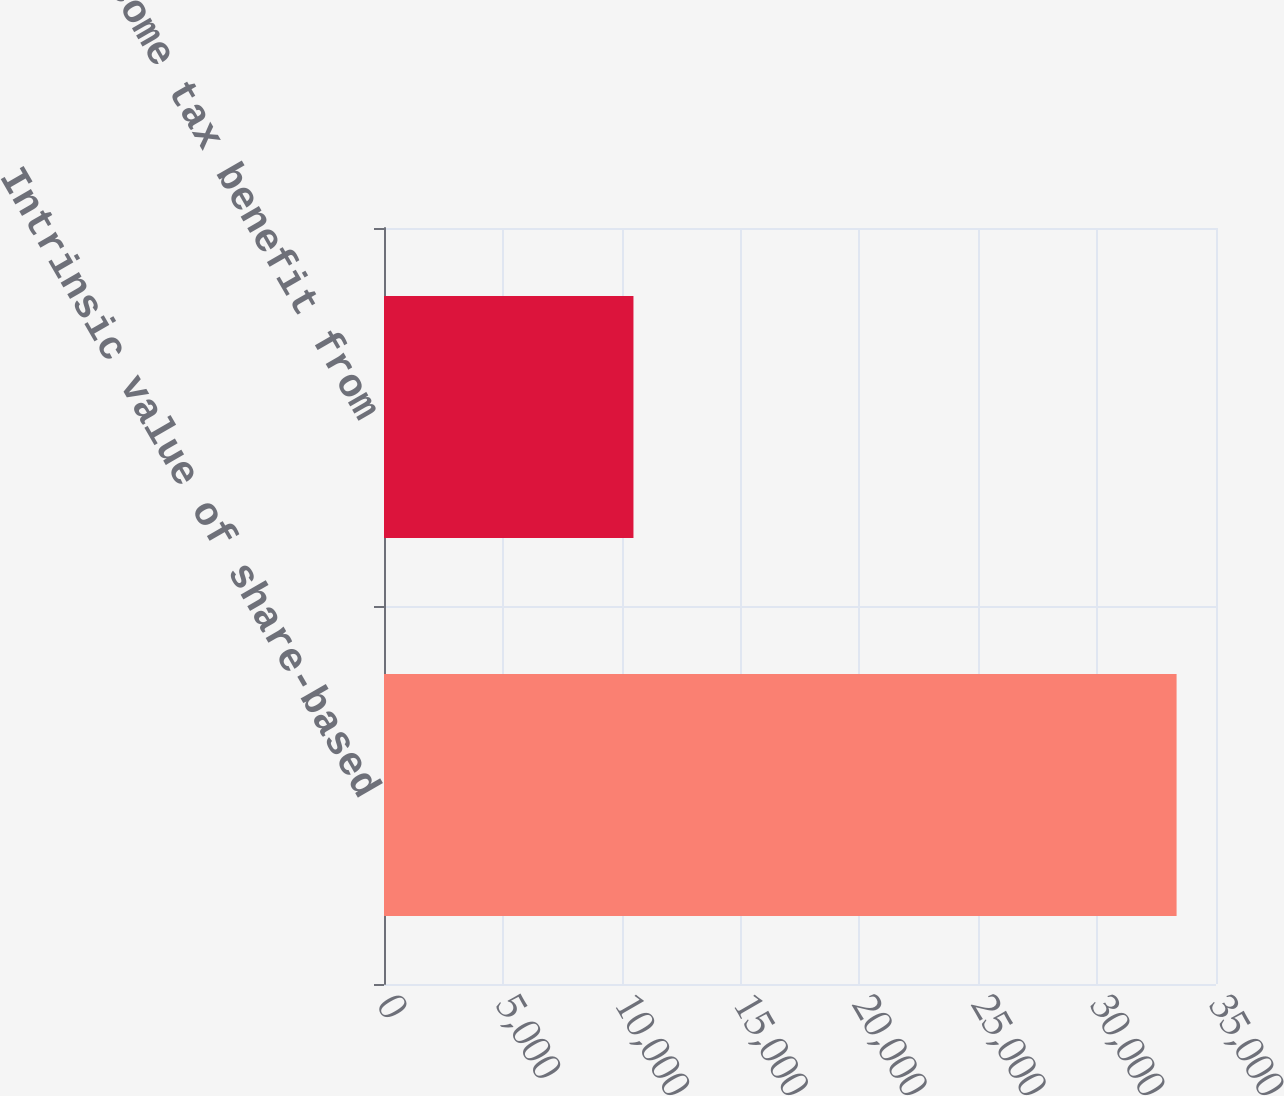Convert chart to OTSL. <chart><loc_0><loc_0><loc_500><loc_500><bar_chart><fcel>Intrinsic value of share-based<fcel>Income tax benefit from<nl><fcel>33342<fcel>10494<nl></chart> 